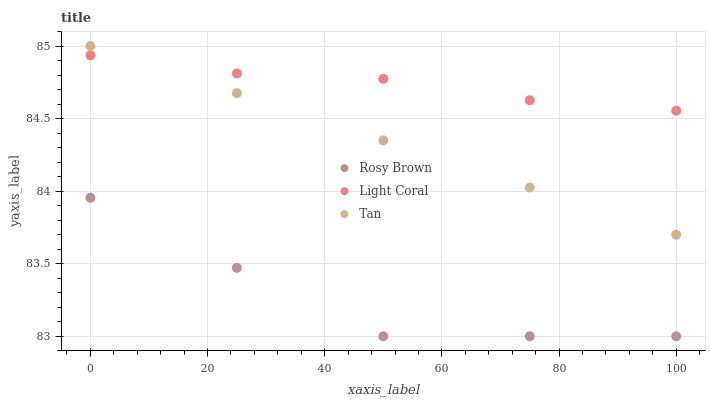Does Rosy Brown have the minimum area under the curve?
Answer yes or no. Yes. Does Light Coral have the maximum area under the curve?
Answer yes or no. Yes. Does Tan have the minimum area under the curve?
Answer yes or no. No. Does Tan have the maximum area under the curve?
Answer yes or no. No. Is Tan the smoothest?
Answer yes or no. Yes. Is Rosy Brown the roughest?
Answer yes or no. Yes. Is Rosy Brown the smoothest?
Answer yes or no. No. Is Tan the roughest?
Answer yes or no. No. Does Rosy Brown have the lowest value?
Answer yes or no. Yes. Does Tan have the lowest value?
Answer yes or no. No. Does Tan have the highest value?
Answer yes or no. Yes. Does Rosy Brown have the highest value?
Answer yes or no. No. Is Rosy Brown less than Light Coral?
Answer yes or no. Yes. Is Light Coral greater than Rosy Brown?
Answer yes or no. Yes. Does Light Coral intersect Tan?
Answer yes or no. Yes. Is Light Coral less than Tan?
Answer yes or no. No. Is Light Coral greater than Tan?
Answer yes or no. No. Does Rosy Brown intersect Light Coral?
Answer yes or no. No. 